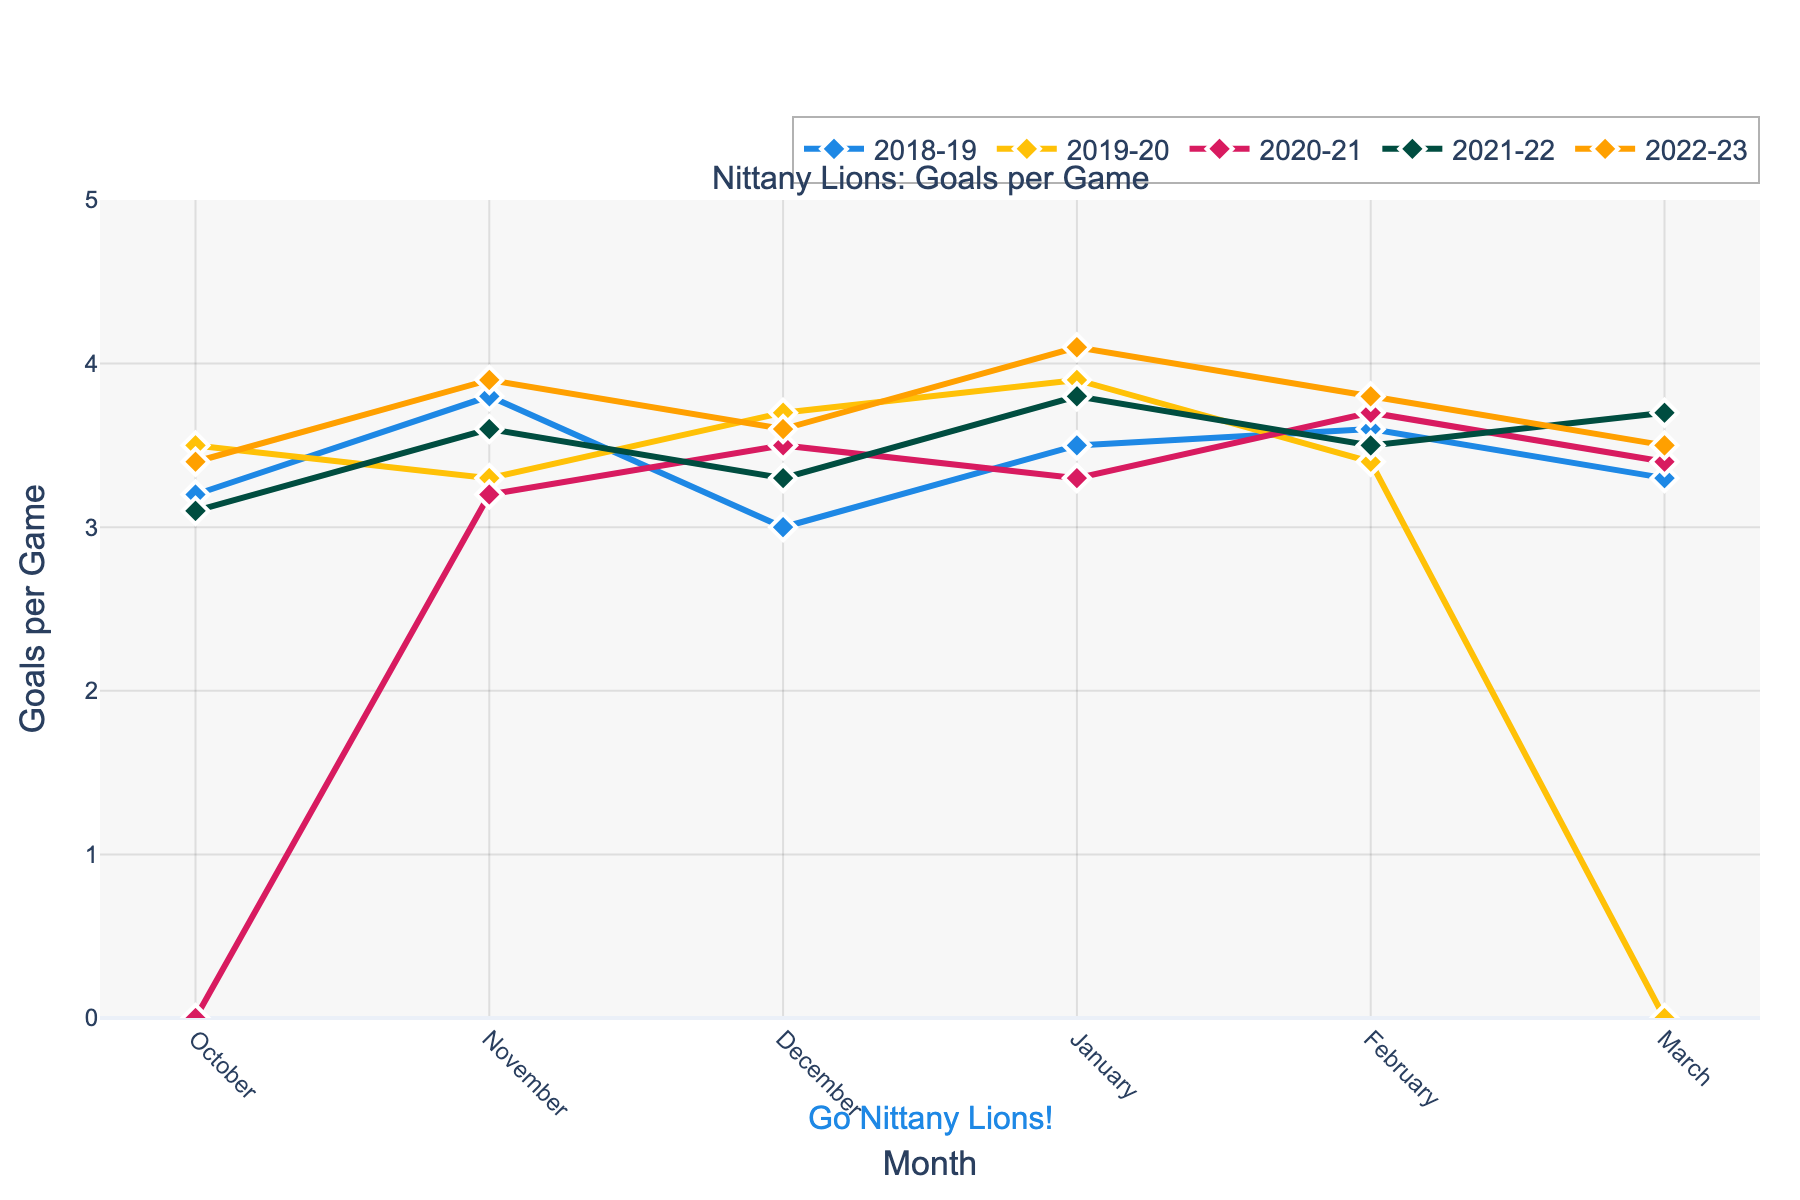How did the goals scored per game in October 2020-21 compare to the other years? 2020-21 had 0 goals per game in October, significantly lower compared to 3.2 in 2018-19, 3.5 in 2019-20, 3.1 in 2021-22, and 3.4 in 2022-23.
Answer: Lower Which month showed the highest average goals per game across all five years? Calculate the average goals per game for each month and compare them:
- October: (3.2 + 3.5 + 0 + 3.1 + 3.4) / 5 = 2.64
- November: (3.8 + 3.3 + 3.2 + 3.6 + 3.9) / 5 = 3.56
- December: (3.0 + 3.7 + 3.5 + 3.3 + 3.6) / 5 = 3.42
- January: (3.5 + 3.9 + 3.3 + 3.8 + 4.1) / 5 = 3.72
- February: (3.6 + 3.4 + 3.7 + 3.5 + 3.8) / 5 = 3.6
- March: (3.3 + 0 + 3.4 + 3.7 + 3.5) / 5 = 2.78 
January has the highest average with 3.72 goals per game.
Answer: January By how much did goals per game increase from October to November in 2022-23? Subtract the goals per game in October from November in 2022-23: 3.9 - 3.4 = 0.5.
Answer: 0.5 In which year did the Nittany Lions have the lowest goals per game in March? The goals per game in March were: 
- 2018-19: 3.3
- 2019-20: 0
- 2020-21: 3.4
- 2021-22: 3.7
- 2022-23: 3.5 
2019-20 had the lowest goals per game with 0.
Answer: 2019-20 Did the goals per game in February ever surpass those in January in any year? Compare February and January data for each year:
- 2018-19: January (3.5), February (3.6)
- 2019-20: January (3.9), February (3.4)
- 2020-21: January (3.3), February (3.7)
- 2021-22: January (3.8), February (3.5)
- 2022-23: January (4.1), February (3.8) 
In 2018-19 and 2020-21, February's goals per game were higher than January's.
Answer: Yes, 2018-19 and 2020-21 Which year had the most consistent goals per game across all months? Calculate the range (max - min) of goals per game for each year:
- 2018-19: 3.8 - 3.0 = 0.8
- 2019-20: 3.9 - 0 = 3.9
- 2020-21: 3.7 - 0 = 3.7
- 2021-22: 3.8 - 3.1 = 0.7
- 2022-23: 4.1 - 3.4 = 0.7
The smallest range is 0.7, occurring in 2021-22 and 2022-23.
Answer: 2021-22 and 2022-23 Did the Nittany Lions improve their goals per game performance by March 2022-23 compared to March 2021-22? Compare the goals per game in March for 2021-22 and 2022-23: 3.7 in 2021-22 and 3.5 in 2022-23. The performance decreased by 0.2.
Answer: No Which year had the highest single-month goals per game, and what was the value? Identify the highest value from the data:
- 2018-19: maximum is 3.8 in November
- 2019-20: maximum is 3.9 in January
- 2020-21: maximum is 3.7 in February
- 2021-22: maximum is 3.8 in January and March
- 2022-23: maximum is 4.1 in January
The highest single-month goals per game is 4.1 in January 2022-23.
Answer: 2022-23, 4.1 How many months did the Nittany Lions have a goals per game value of 3.5 or higher in 2019-20? Count the months in 2019-20 with goals per game ≥ 3.5:
- October: 3.5, November: 3.3, December: 3.7, January: 3.9, February: 3.4, March: 0
There are 3 months (October, December, and January) where goals per game were 3.5 or higher.
Answer: 3 Which year had the sharpest drop in goals per game from one month to the next, and by how much? Calculate month-to-month changes for each year and find the maximum drop:
- 2018-19: Nov-Dec: 3.8-3.0 = 0.8
- 2019-20: Feb-Mar: 3.4-0 = 3.4
- 2020-21: Oct-Nov: 3.2-0 = 3.2
- 2021-22: Oct-Nov: 3.1-3.6 = -0.5
- 2022-23: Nov-Dec: 3.9-3.6 = 0.3
The sharpest drop was in 2019-20 from February to March with a decrease of 3.4 goals per game.
Answer: 2019-20, 3.4 